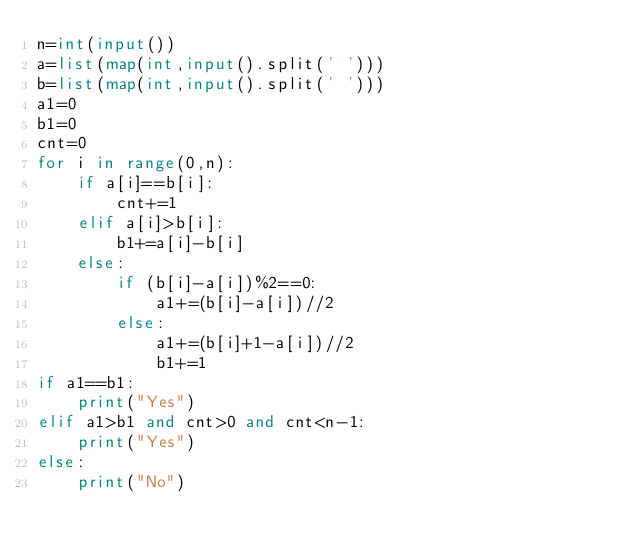<code> <loc_0><loc_0><loc_500><loc_500><_Python_>n=int(input())
a=list(map(int,input().split(' ')))
b=list(map(int,input().split(' ')))
a1=0
b1=0
cnt=0
for i in range(0,n):
    if a[i]==b[i]:
        cnt+=1
    elif a[i]>b[i]:
        b1+=a[i]-b[i]
    else:
        if (b[i]-a[i])%2==0:
            a1+=(b[i]-a[i])//2
        else:
            a1+=(b[i]+1-a[i])//2
            b1+=1
if a1==b1:
    print("Yes")
elif a1>b1 and cnt>0 and cnt<n-1:
    print("Yes")
else:
    print("No")
        </code> 